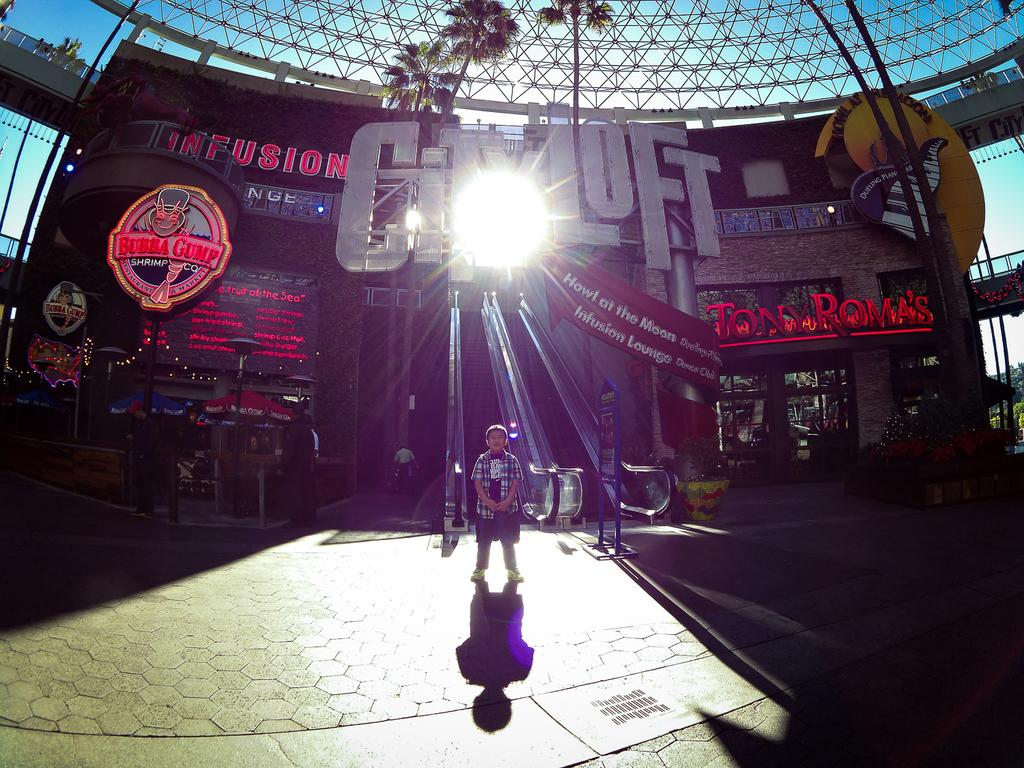What is the main subject of the image? There is a boy standing in the middle of the image. What can be seen in the background of the image? There is a building, banners, trees, and bridges in the background of the image. From where do you think the image was taken? The image appears to be taken from a rooftop. What type of question is being asked by the boy in the image? There is no indication in the image that the boy is asking a question. Can you tell me what flavor of cracker the boy is holding in the image? There is no cracker present in the image, so it cannot be determined what flavor it might be. 